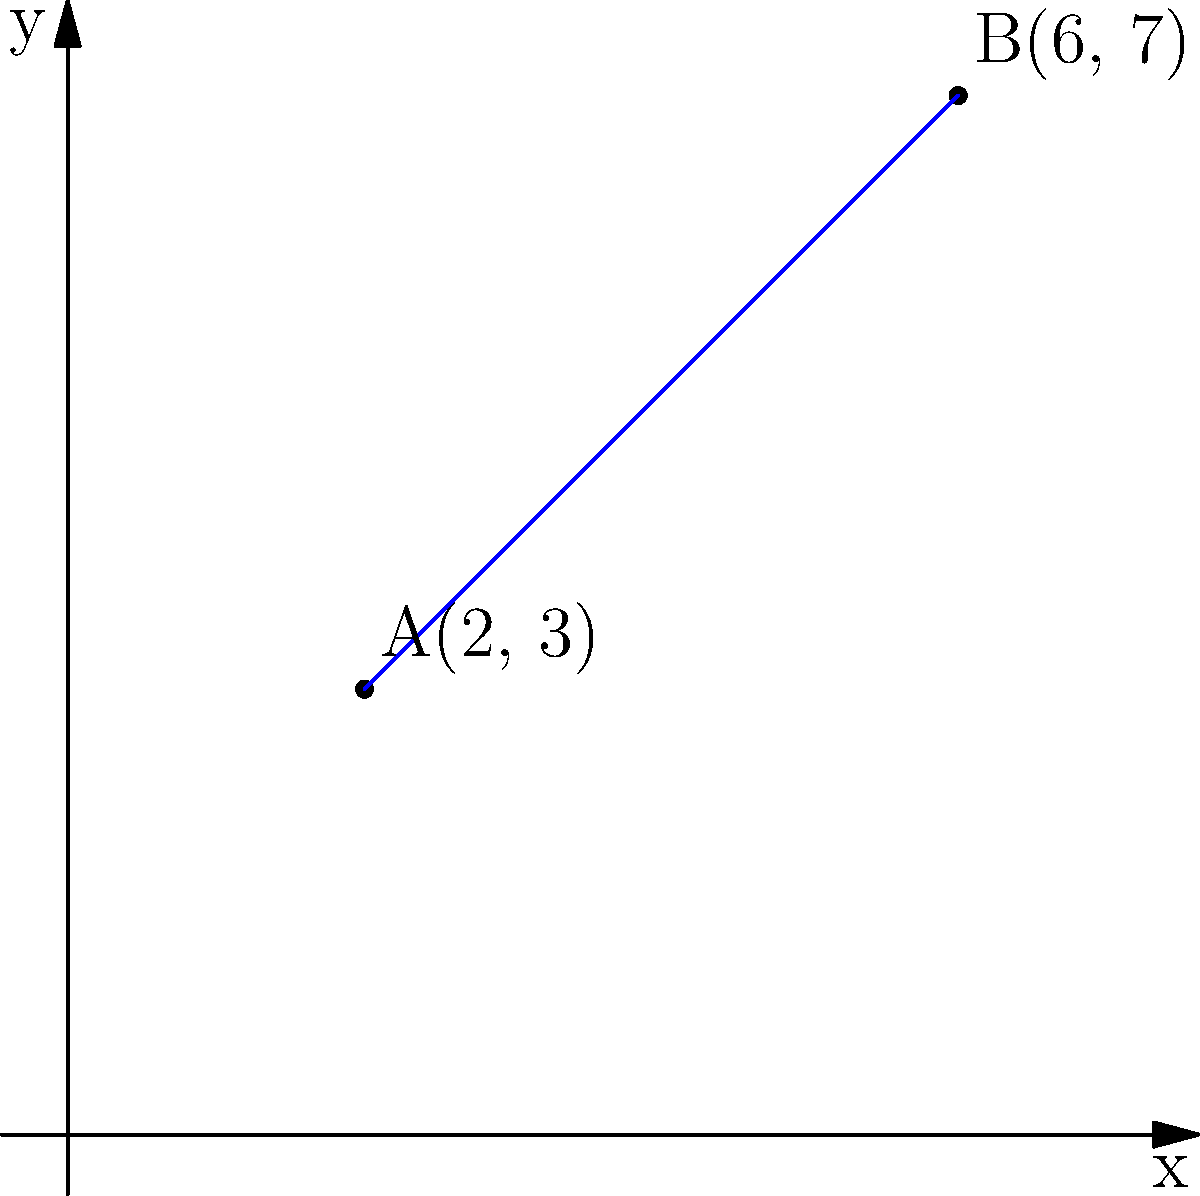As an international recruiter, you often need to assess candidates' problem-solving skills. Consider two points on a coordinate plane representing the locations of two potential candidates: A(2, 3) and B(6, 7). Calculate the distance between these two points to determine which candidate is closer to the company's office. To find the distance between two points on a coordinate plane, we can use the distance formula:

$$d = \sqrt{(x_2 - x_1)^2 + (y_2 - y_1)^2}$$

Where $(x_1, y_1)$ represents the coordinates of point A, and $(x_2, y_2)$ represents the coordinates of point B.

Let's follow these steps:

1. Identify the coordinates:
   Point A: $(x_1, y_1) = (2, 3)$
   Point B: $(x_2, y_2) = (6, 7)$

2. Substitute these values into the distance formula:
   $$d = \sqrt{(6 - 2)^2 + (7 - 3)^2}$$

3. Simplify the expressions inside the parentheses:
   $$d = \sqrt{4^2 + 4^2}$$

4. Calculate the squares:
   $$d = \sqrt{16 + 16}$$

5. Add the values under the square root:
   $$d = \sqrt{32}$$

6. Simplify the square root:
   $$d = 4\sqrt{2}$$

Therefore, the distance between points A and B is $4\sqrt{2}$ units.
Answer: $4\sqrt{2}$ units 